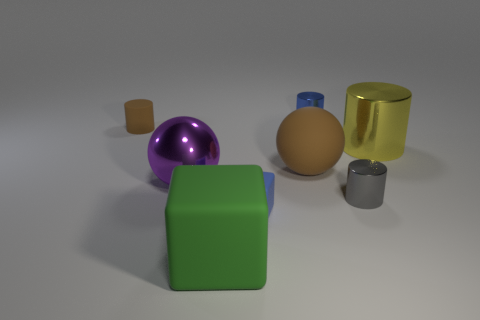Subtract all metal cylinders. How many cylinders are left? 1 Add 1 small gray matte balls. How many objects exist? 9 Subtract all blue cubes. How many cubes are left? 1 Subtract all spheres. How many objects are left? 6 Subtract all green things. Subtract all brown cylinders. How many objects are left? 6 Add 7 big green cubes. How many big green cubes are left? 8 Add 5 rubber balls. How many rubber balls exist? 6 Subtract 1 blue cylinders. How many objects are left? 7 Subtract 1 balls. How many balls are left? 1 Subtract all cyan spheres. Subtract all yellow cylinders. How many spheres are left? 2 